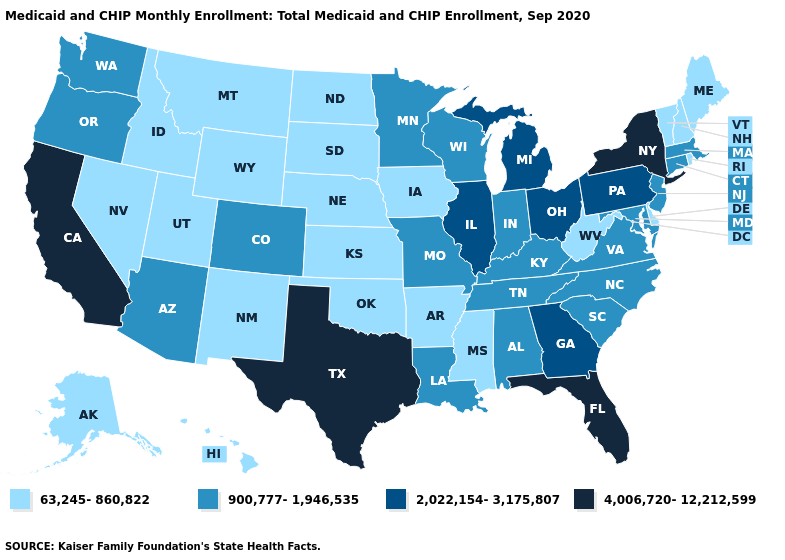What is the value of New Hampshire?
Keep it brief. 63,245-860,822. Does California have the highest value in the West?
Be succinct. Yes. Does New York have the lowest value in the Northeast?
Answer briefly. No. What is the value of Minnesota?
Give a very brief answer. 900,777-1,946,535. What is the value of New Jersey?
Give a very brief answer. 900,777-1,946,535. What is the value of Tennessee?
Answer briefly. 900,777-1,946,535. Name the states that have a value in the range 2,022,154-3,175,807?
Quick response, please. Georgia, Illinois, Michigan, Ohio, Pennsylvania. What is the value of Nebraska?
Short answer required. 63,245-860,822. Does New Hampshire have the lowest value in the USA?
Short answer required. Yes. What is the highest value in the Northeast ?
Concise answer only. 4,006,720-12,212,599. What is the value of North Carolina?
Answer briefly. 900,777-1,946,535. Does the map have missing data?
Be succinct. No. What is the value of Iowa?
Short answer required. 63,245-860,822. What is the lowest value in the USA?
Answer briefly. 63,245-860,822. 